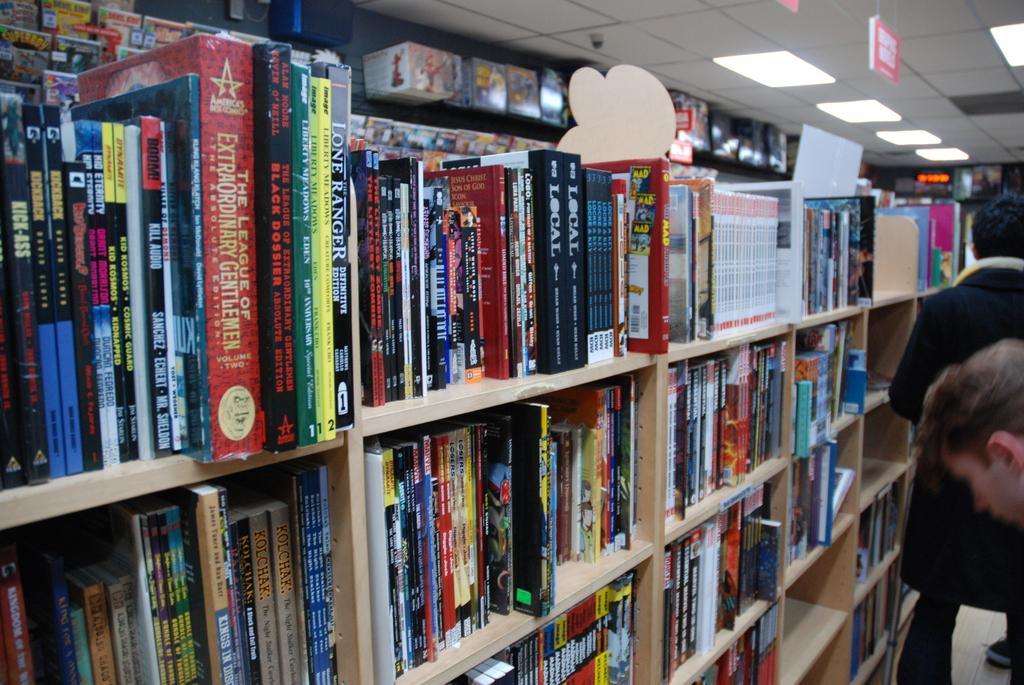The league of extraordinary what?
Your response must be concise. Gentlemen. What is the title of the first book at the right?
Ensure brevity in your answer.  Kick-ass. 